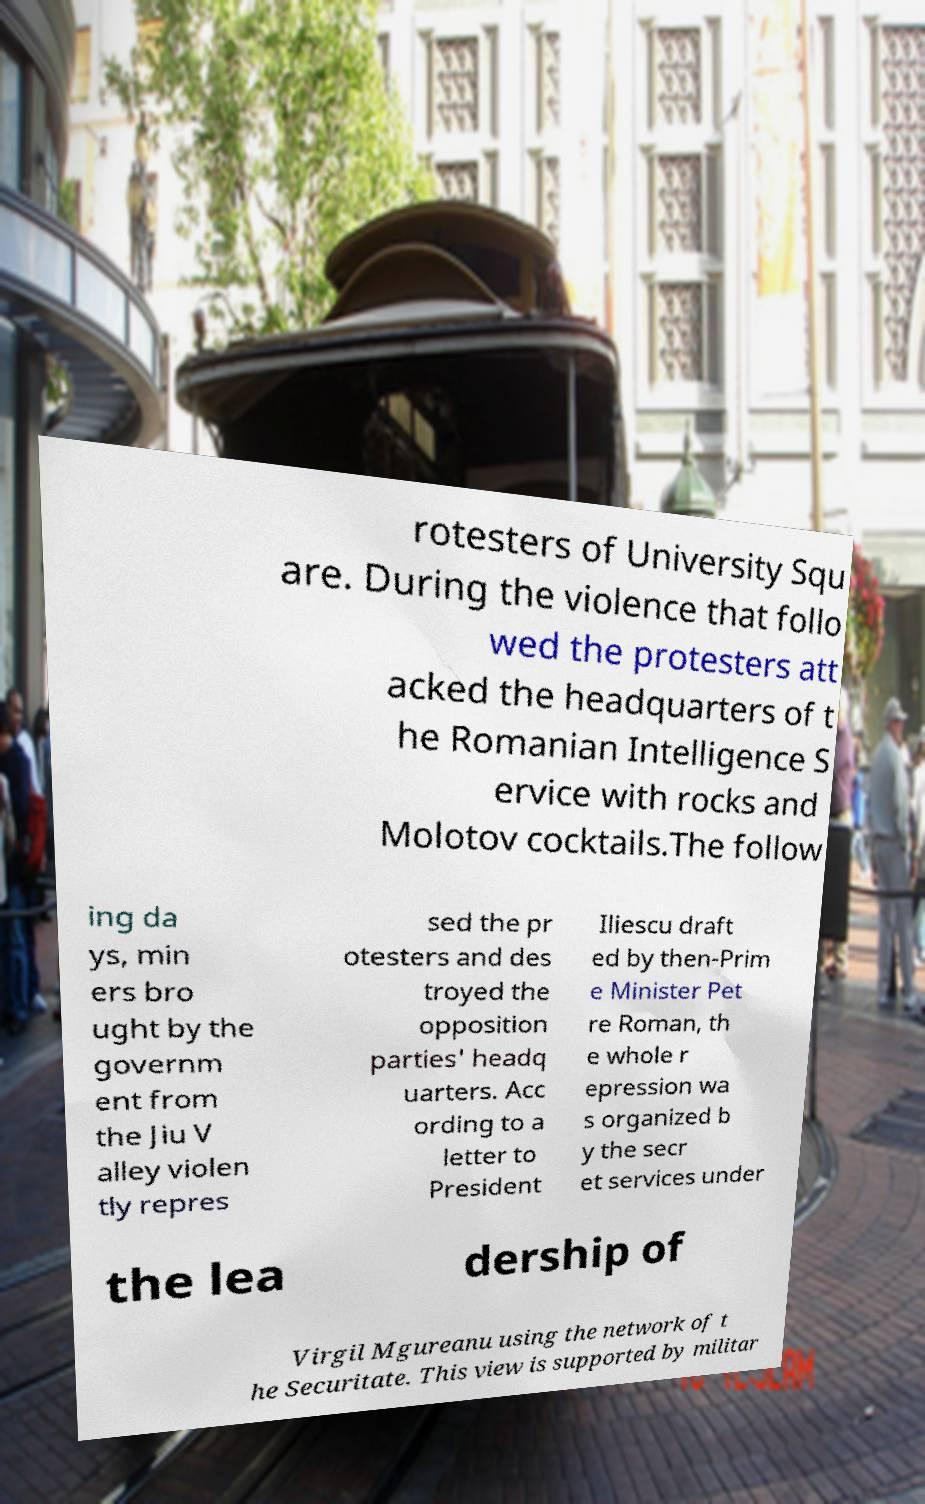Could you extract and type out the text from this image? rotesters of University Squ are. During the violence that follo wed the protesters att acked the headquarters of t he Romanian Intelligence S ervice with rocks and Molotov cocktails.The follow ing da ys, min ers bro ught by the governm ent from the Jiu V alley violen tly repres sed the pr otesters and des troyed the opposition parties' headq uarters. Acc ording to a letter to President Iliescu draft ed by then-Prim e Minister Pet re Roman, th e whole r epression wa s organized b y the secr et services under the lea dership of Virgil Mgureanu using the network of t he Securitate. This view is supported by militar 